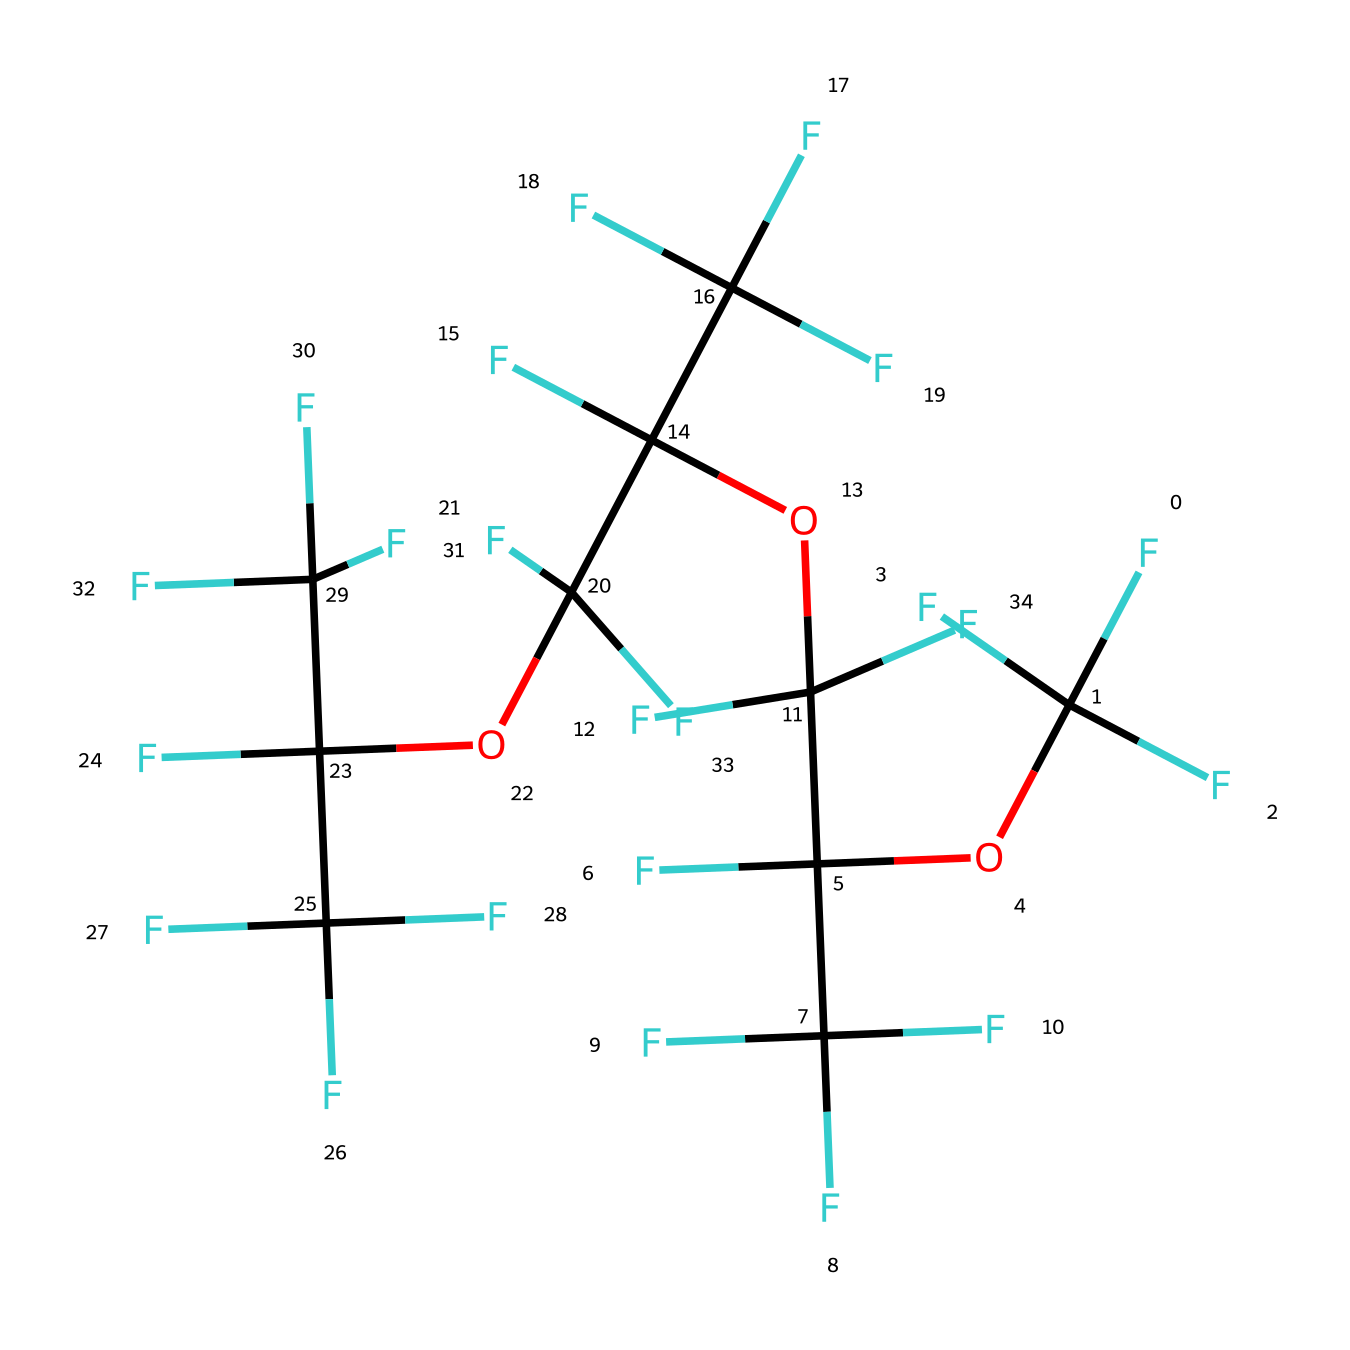What is the main functional group in this chemical? The structure shows the presence of ether linkages, as indicated by the presence of the "OC" segments in the SMILES representation. These ether linkages serve as the main functional group in this PFPE lubricant.
Answer: ether How many carbon atoms are present in the molecule? By analyzing the SMILES notation, each "C" represents a carbon atom. Counting all instances, there are a total of 12 carbon atoms present in the molecule.
Answer: 12 What is the primary type of bond found between atoms in this molecule? The molecule primarily consists of single bonds (sigma bonds) between carbon and oxygen atoms, as well as carbon-fluorine bonds. The lack of any double or triple bonds in the SMILES indicates single bonds are predominant.
Answer: single bond Which type of intermolecular forces would you expect this lubricant to exhibit? Given the large presence of fluorinated groups in the structure, this compound is likely to exhibit strong van der Waals forces due to the size and electronegativity of fluorine atoms. This would influence its physical properties significantly.
Answer: van der Waals forces Is this lubricant hydrophobic or hydrophilic? The high fluorine content in the structure implies a strong hydrophobic character, as fluorinated compounds tend to repel water and are nonpolar. Therefore, this lubricant is expected to be hydrophobic.
Answer: hydrophobic What characteristic property does the fluorinated structure impart to this lubricant? The fluorinated structure enhances chemical stability and thermal resistance, making the lubricant suitable for high-vacuum applications, where these properties are critical.
Answer: thermal resistance 